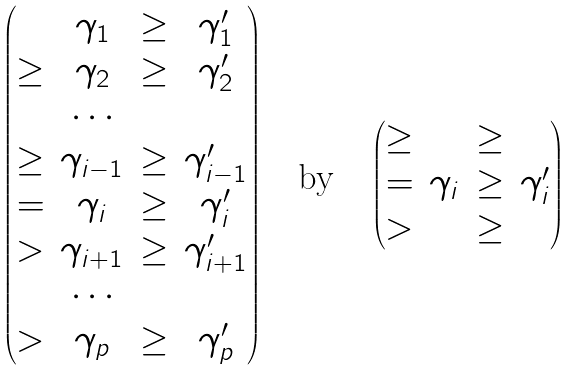Convert formula to latex. <formula><loc_0><loc_0><loc_500><loc_500>\begin{pmatrix} & \gamma _ { 1 } & \geq & \gamma ^ { \prime } _ { 1 } \\ \geq & \gamma _ { 2 } & \geq & \gamma ^ { \prime } _ { 2 } \\ & \cdots \\ \geq & \gamma _ { i - 1 } & \geq & \gamma ^ { \prime } _ { i - 1 } \\ = & \gamma _ { i } & \geq & \gamma ^ { \prime } _ { i } \\ > & \gamma _ { i + 1 } & \geq & \gamma ^ { \prime } _ { i + 1 } \\ & \cdots \\ > & \gamma _ { p } & \geq & \gamma ^ { \prime } _ { p } \end{pmatrix} \quad \text {by} \quad \begin{pmatrix} \geq & & \geq \\ = & \gamma _ { i } & \geq & \gamma ^ { \prime } _ { i } \\ > & & \geq \end{pmatrix}</formula> 